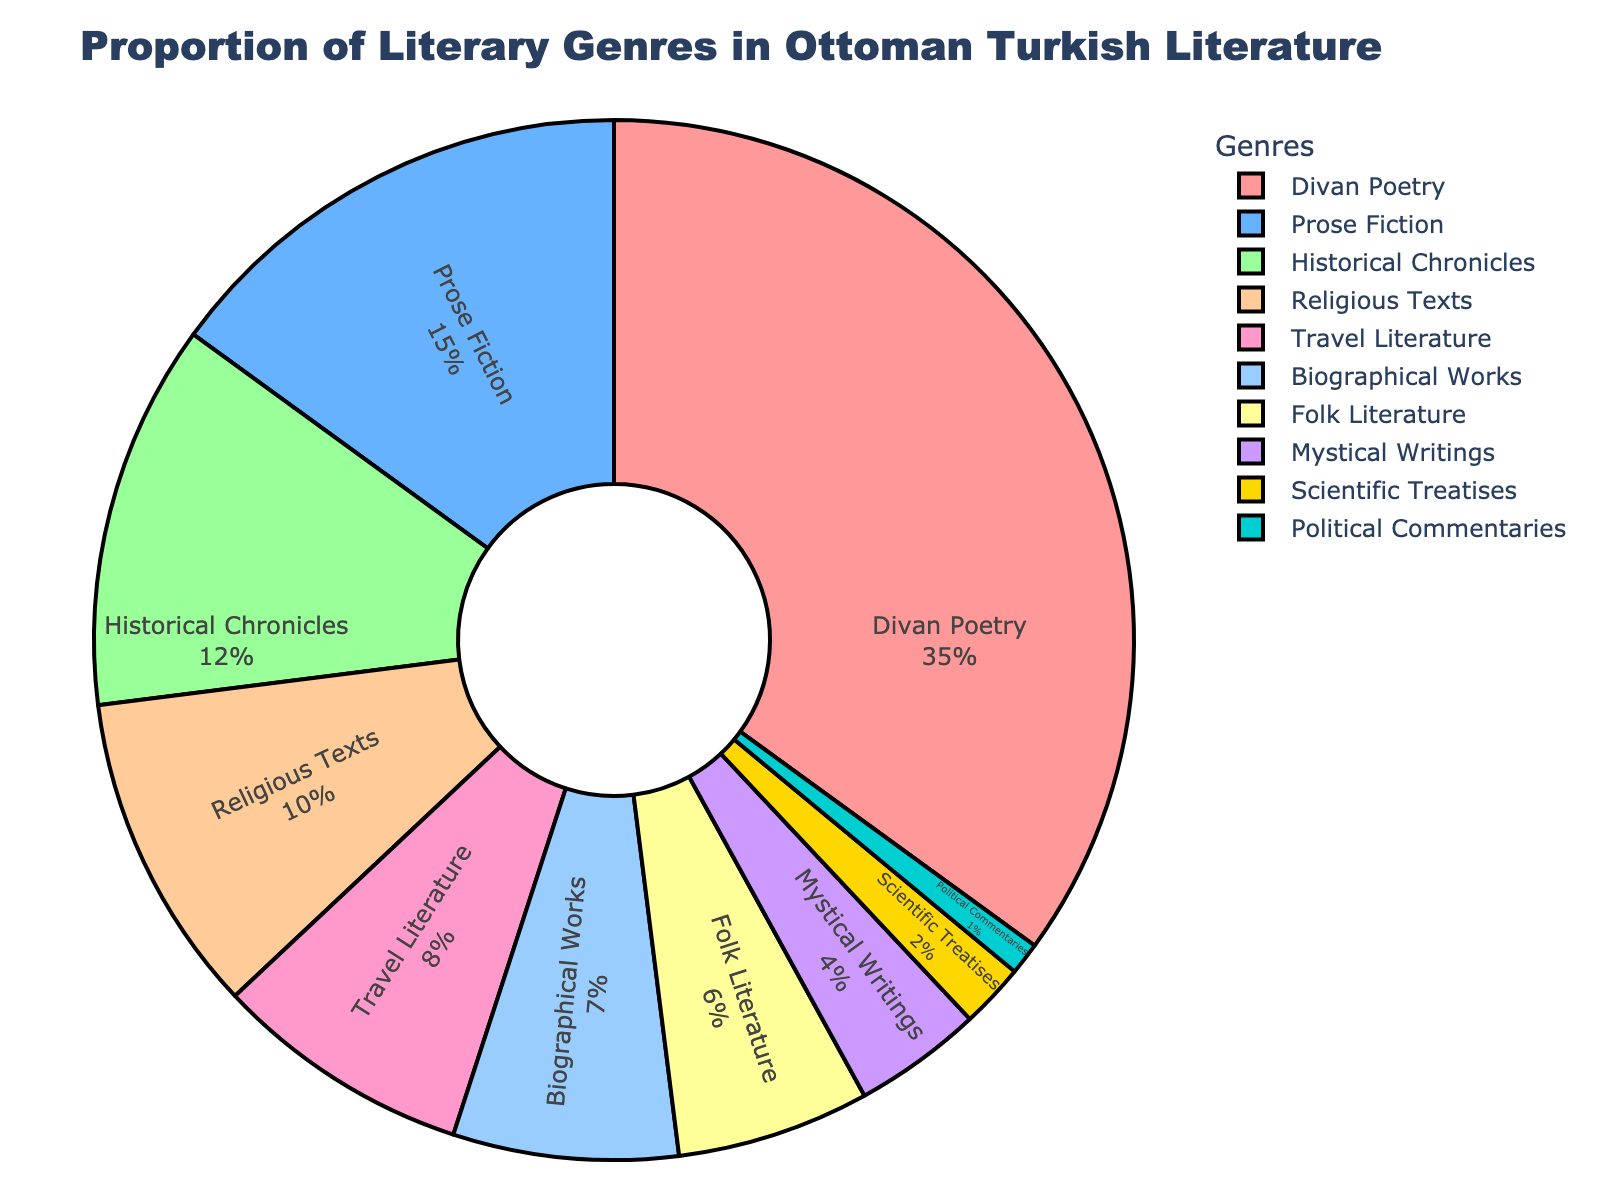What is the largest literary genre in the Ottoman Turkish literature according to the pie chart? The pie chart shows that the 'Divan Poetry' section occupies the largest portion, prominently displayed in the pie chart.
Answer: Divan Poetry What is the combined percentage of 'Historical Chronicles' and 'Religious Texts'? According to the pie chart, 'Historical Chronicles' is 12% and 'Religious Texts' is 10%. Adding these percentages together gives 12% + 10% = 22%.
Answer: 22% Which genre has a greater representation: 'Biographical Works' or 'Travel Literature'? From the pie chart, 'Travel Literature' is 8% while 'Biographical Works' is 7%. Therefore, 'Travel Literature' has a greater representation.
Answer: Travel Literature How much more is the proportion of 'Divan Poetry' compared to 'Scientific Treatises'? 'Divan Poetry' is 35% and 'Scientific Treatises' is 2%. The difference is calculated by subtracting the smaller percentage from the larger one: 35% - 2% = 33%.
Answer: 33% Which genres constitute exactly 10% and below in the pie chart? The chart displays 'Religious Texts' (10%), 'Travel Literature' (8%), 'Biographical Works' (7%), 'Folk Literature' (6%), 'Mystical Writings' (4%), 'Scientific Treatises' (2%), and 'Political Commentaries' (1%) as the genres with percentages of 10% and below.
Answer: Religious Texts, Travel Literature, Biographical Works, Folk Literature, Mystical Writings, Scientific Treatises, Political Commentaries Which two genres together make up the smallest combined percentage, and what is that percentage? The genres 'Scientific Treatises' and 'Political Commentaries' have the smallest individual percentages, which are 2% and 1% respectively. Adding these gives 2% + 1% = 3%.
Answer: Scientific Treatises and Political Commentaries, 3% What is the difference in percentage between the most and least common genres? The most common genre is 'Divan Poetry' at 35% and the least common is 'Political Commentaries' at 1%. The percentage difference is 35% - 1% = 34%.
Answer: 34% Which color represents 'Prose Fiction' and what is its approximate location on the pie chart? The color representing 'Prose Fiction' on the pie chart is blue, and it is located in the upper right segment of the chart, occupying 15% of the space.
Answer: Blue, upper right segment What is the total percentage of all genres that fall into the category of non-fiction (e.g., 'Historical Chronicles', 'Religious Texts', 'Travel Literature', 'Biographical Works', 'Scientific Treatises', 'Political Commentaries')? Adding the percentages of these genres from the pie chart: Historical Chronicles (12%), Religious Texts (10%), Travel Literature (8%), Biographical Works (7%), Scientific Treatises (2%), Political Commentaries (1%) gives 12% + 10% + 8% + 7% + 2% + 1% = 40%.
Answer: 40% 